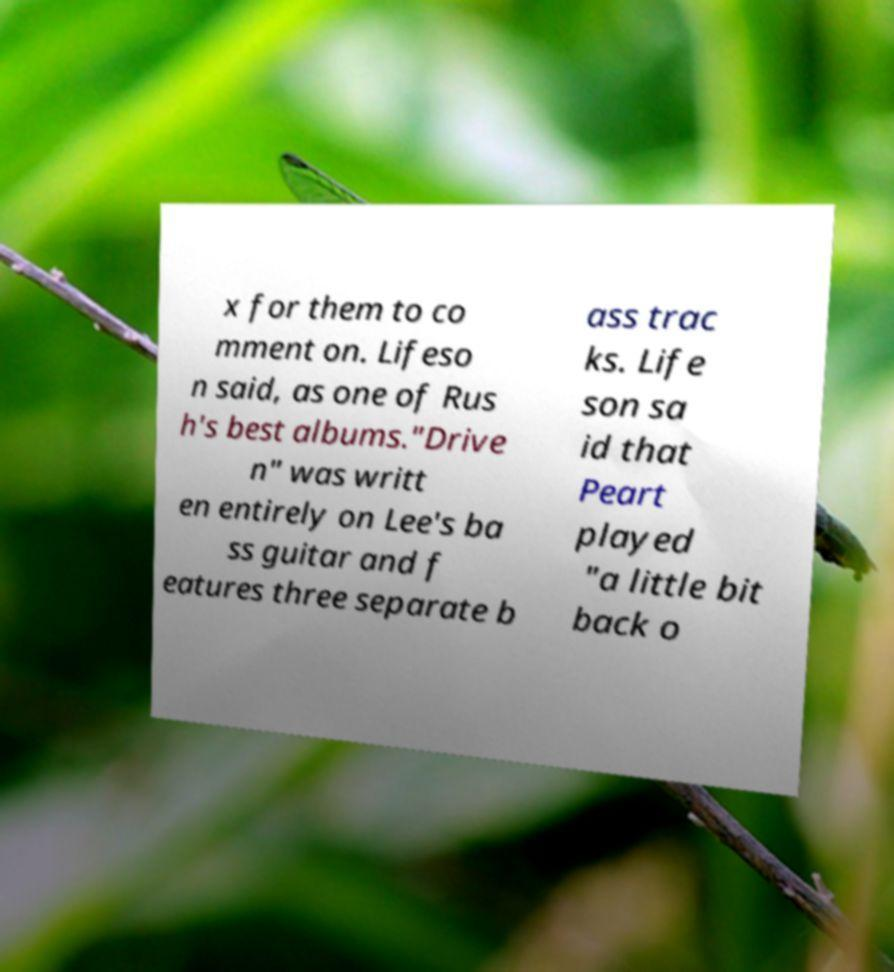Please read and relay the text visible in this image. What does it say? x for them to co mment on. Lifeso n said, as one of Rus h's best albums."Drive n" was writt en entirely on Lee's ba ss guitar and f eatures three separate b ass trac ks. Life son sa id that Peart played "a little bit back o 